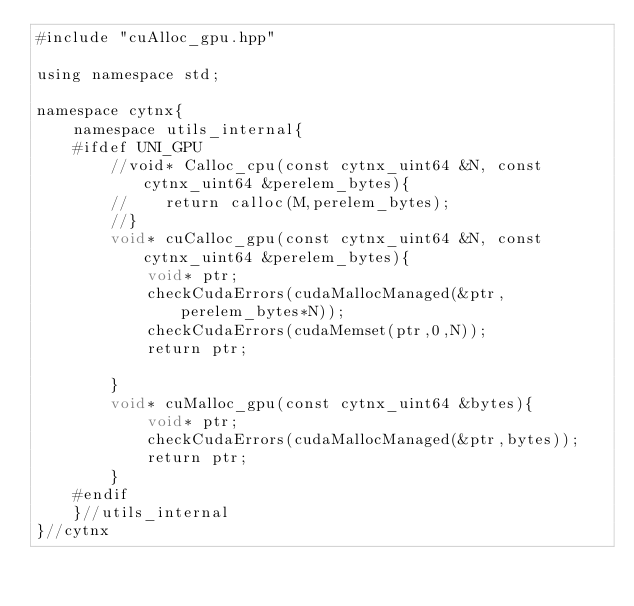Convert code to text. <code><loc_0><loc_0><loc_500><loc_500><_Cuda_>#include "cuAlloc_gpu.hpp"

using namespace std;

namespace cytnx{
    namespace utils_internal{
    #ifdef UNI_GPU
        //void* Calloc_cpu(const cytnx_uint64 &N, const cytnx_uint64 &perelem_bytes){
        //    return calloc(M,perelem_bytes);
        //}
        void* cuCalloc_gpu(const cytnx_uint64 &N, const cytnx_uint64 &perelem_bytes){
            void* ptr;
            checkCudaErrors(cudaMallocManaged(&ptr,perelem_bytes*N));
            checkCudaErrors(cudaMemset(ptr,0,N));
            return ptr;

        }
        void* cuMalloc_gpu(const cytnx_uint64 &bytes){
            void* ptr;
            checkCudaErrors(cudaMallocManaged(&ptr,bytes));
            return ptr;
        }
    #endif
    }//utils_internal
}//cytnx
</code> 